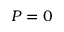Convert formula to latex. <formula><loc_0><loc_0><loc_500><loc_500>P = 0</formula> 